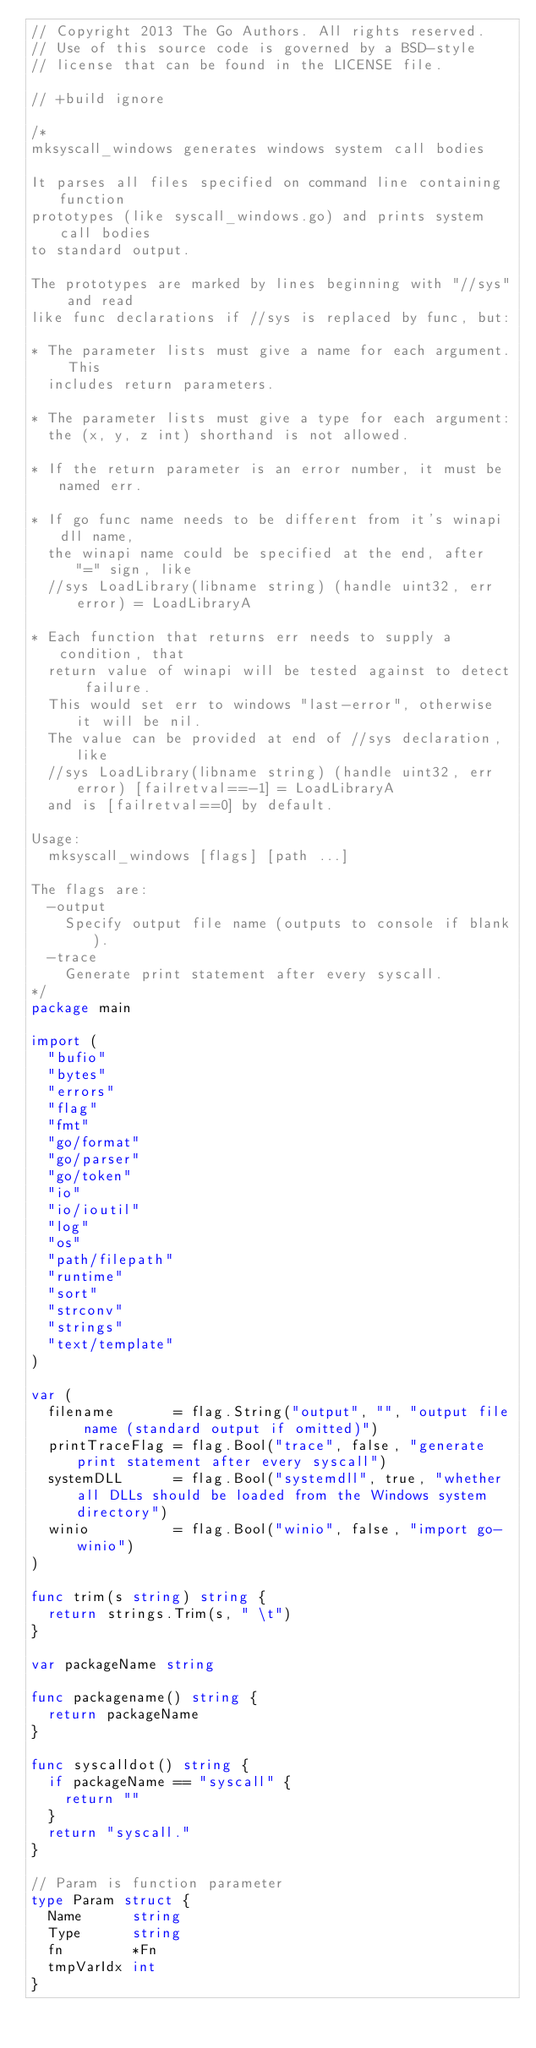<code> <loc_0><loc_0><loc_500><loc_500><_Go_>// Copyright 2013 The Go Authors. All rights reserved.
// Use of this source code is governed by a BSD-style
// license that can be found in the LICENSE file.

// +build ignore

/*
mksyscall_windows generates windows system call bodies

It parses all files specified on command line containing function
prototypes (like syscall_windows.go) and prints system call bodies
to standard output.

The prototypes are marked by lines beginning with "//sys" and read
like func declarations if //sys is replaced by func, but:

* The parameter lists must give a name for each argument. This
  includes return parameters.

* The parameter lists must give a type for each argument:
  the (x, y, z int) shorthand is not allowed.

* If the return parameter is an error number, it must be named err.

* If go func name needs to be different from it's winapi dll name,
  the winapi name could be specified at the end, after "=" sign, like
  //sys LoadLibrary(libname string) (handle uint32, err error) = LoadLibraryA

* Each function that returns err needs to supply a condition, that
  return value of winapi will be tested against to detect failure.
  This would set err to windows "last-error", otherwise it will be nil.
  The value can be provided at end of //sys declaration, like
  //sys LoadLibrary(libname string) (handle uint32, err error) [failretval==-1] = LoadLibraryA
  and is [failretval==0] by default.

Usage:
	mksyscall_windows [flags] [path ...]

The flags are:
	-output
		Specify output file name (outputs to console if blank).
	-trace
		Generate print statement after every syscall.
*/
package main

import (
	"bufio"
	"bytes"
	"errors"
	"flag"
	"fmt"
	"go/format"
	"go/parser"
	"go/token"
	"io"
	"io/ioutil"
	"log"
	"os"
	"path/filepath"
	"runtime"
	"sort"
	"strconv"
	"strings"
	"text/template"
)

var (
	filename       = flag.String("output", "", "output file name (standard output if omitted)")
	printTraceFlag = flag.Bool("trace", false, "generate print statement after every syscall")
	systemDLL      = flag.Bool("systemdll", true, "whether all DLLs should be loaded from the Windows system directory")
	winio          = flag.Bool("winio", false, "import go-winio")
)

func trim(s string) string {
	return strings.Trim(s, " \t")
}

var packageName string

func packagename() string {
	return packageName
}

func syscalldot() string {
	if packageName == "syscall" {
		return ""
	}
	return "syscall."
}

// Param is function parameter
type Param struct {
	Name      string
	Type      string
	fn        *Fn
	tmpVarIdx int
}
</code> 